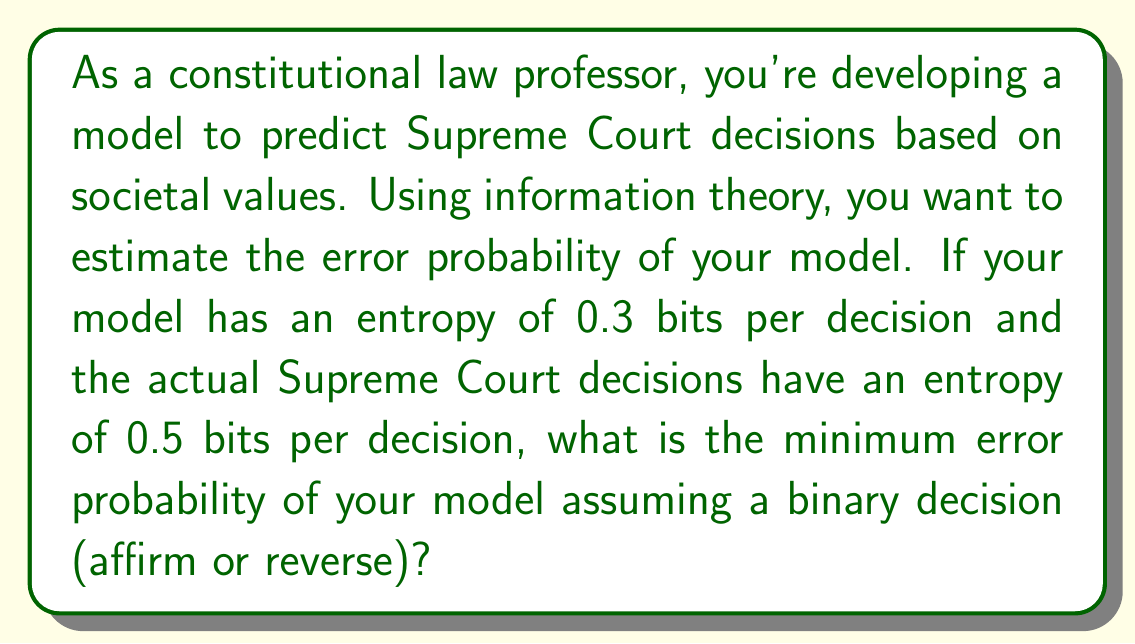Could you help me with this problem? To solve this problem, we'll use the Fano inequality from information theory. The Fano inequality provides a lower bound on the error probability of any decoder (in this case, our prediction model) given the entropy of the source (actual Supreme Court decisions) and the mutual information between the source and the decoder's output.

Let's define our variables:
$H(X)$ = Entropy of actual Supreme Court decisions = 0.5 bits
$H(Y)$ = Entropy of our model's predictions = 0.3 bits
$P_e$ = Error probability we want to find

The Fano inequality states:

$$H(P_e) + P_e \log_2(|X| - 1) \geq H(X|Y)$$

Where $|X|$ is the number of possible outcomes (in this case, 2 for affirm or reverse), and $H(X|Y)$ is the conditional entropy of X given Y.

We can calculate $H(X|Y)$ using the relation:

$$H(X|Y) = H(X) - I(X;Y)$$

Where $I(X;Y)$ is the mutual information between X and Y. In the best case scenario, all the information in our model's predictions ($H(Y)$) is mutual information with the actual decisions. So:

$$I(X;Y) \leq H(Y) = 0.3$$

Therefore:

$$H(X|Y) \geq H(X) - H(Y) = 0.5 - 0.3 = 0.2$$

Now we can apply the Fano inequality:

$$H(P_e) + P_e \log_2(2 - 1) \geq 0.2$$

Simplifying:

$$H(P_e) \geq 0.2$$

The binary entropy function is defined as:

$$H(P_e) = -P_e \log_2(P_e) - (1-P_e) \log_2(1-P_e)$$

We need to find the minimum $P_e$ that satisfies this inequality. This can be done numerically or by using a table of binary entropy function values. The result is approximately 0.0582 or 5.82%.
Answer: The minimum error probability of the model is approximately 0.0582 or 5.82%. 